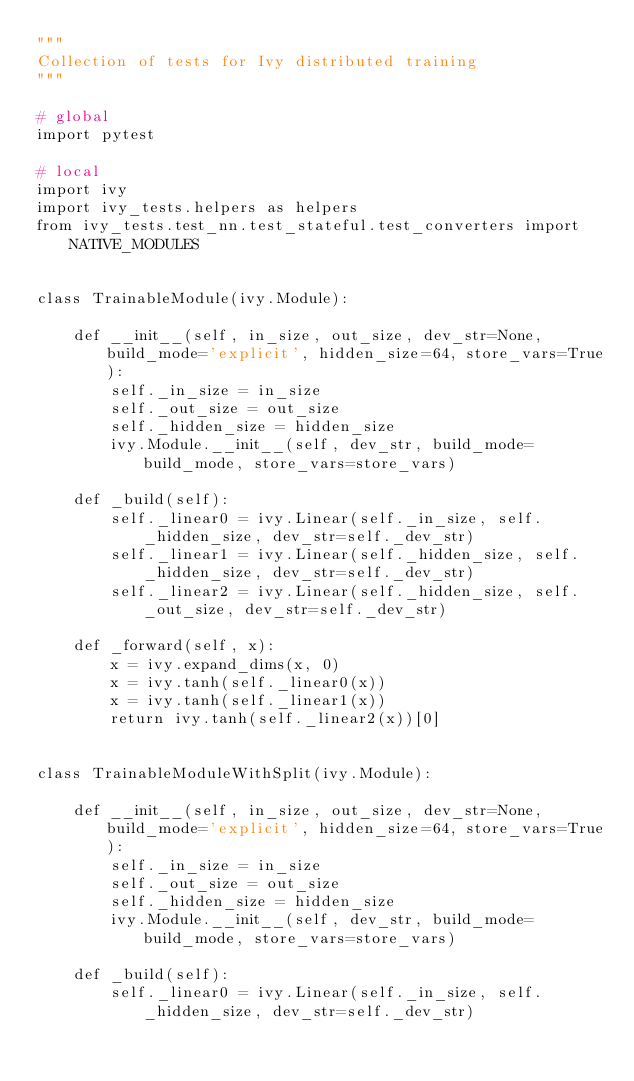<code> <loc_0><loc_0><loc_500><loc_500><_Python_>"""
Collection of tests for Ivy distributed training
"""

# global
import pytest

# local
import ivy
import ivy_tests.helpers as helpers
from ivy_tests.test_nn.test_stateful.test_converters import NATIVE_MODULES


class TrainableModule(ivy.Module):

    def __init__(self, in_size, out_size, dev_str=None, build_mode='explicit', hidden_size=64, store_vars=True):
        self._in_size = in_size
        self._out_size = out_size
        self._hidden_size = hidden_size
        ivy.Module.__init__(self, dev_str, build_mode=build_mode, store_vars=store_vars)

    def _build(self):
        self._linear0 = ivy.Linear(self._in_size, self._hidden_size, dev_str=self._dev_str)
        self._linear1 = ivy.Linear(self._hidden_size, self._hidden_size, dev_str=self._dev_str)
        self._linear2 = ivy.Linear(self._hidden_size, self._out_size, dev_str=self._dev_str)

    def _forward(self, x):
        x = ivy.expand_dims(x, 0)
        x = ivy.tanh(self._linear0(x))
        x = ivy.tanh(self._linear1(x))
        return ivy.tanh(self._linear2(x))[0]


class TrainableModuleWithSplit(ivy.Module):

    def __init__(self, in_size, out_size, dev_str=None, build_mode='explicit', hidden_size=64, store_vars=True):
        self._in_size = in_size
        self._out_size = out_size
        self._hidden_size = hidden_size
        ivy.Module.__init__(self, dev_str, build_mode=build_mode, store_vars=store_vars)

    def _build(self):
        self._linear0 = ivy.Linear(self._in_size, self._hidden_size, dev_str=self._dev_str)</code> 